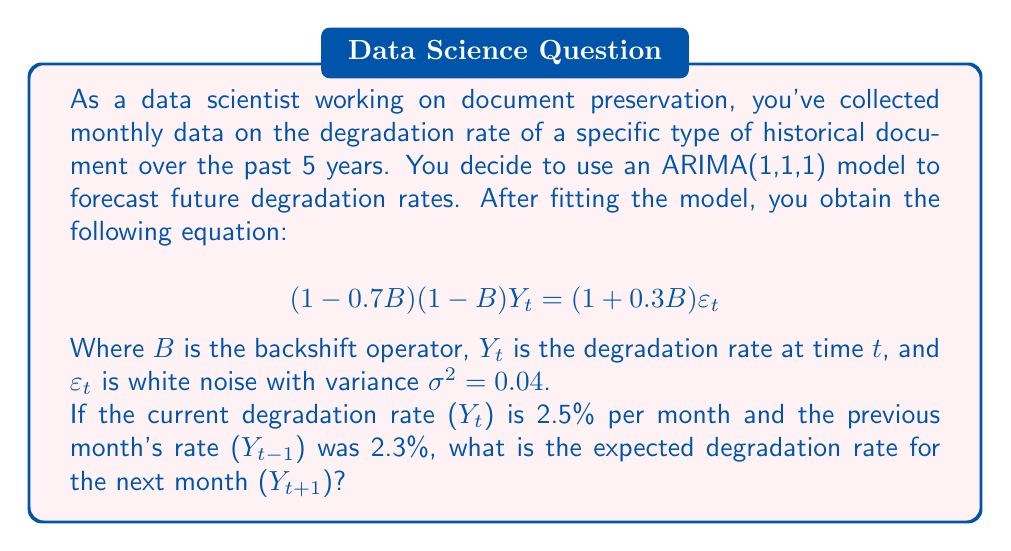Give your solution to this math problem. To solve this problem, we need to follow these steps:

1) First, let's expand the ARIMA(1,1,1) model equation:

   $$(1 - 0.7B)(1 - B)Y_t = (1 + 0.3B)\varepsilon_t$$
   $$(1 - B - 0.7B + 0.7B^2)Y_t = \varepsilon_t + 0.3B\varepsilon_t$$
   $$Y_t - Y_{t-1} - 0.7Y_{t-1} + 0.7Y_{t-2} = \varepsilon_t + 0.3\varepsilon_{t-1}$$

2) Rearrange the equation to isolate $Y_t$:

   $$Y_t = Y_{t-1} + 0.7Y_{t-1} - 0.7Y_{t-2} + \varepsilon_t + 0.3\varepsilon_{t-1}$$
   $$Y_t = 1.7Y_{t-1} - 0.7Y_{t-2} + \varepsilon_t + 0.3\varepsilon_{t-1}$$

3) To forecast $Y_{t+1}$, we shift the time index forward by 1:

   $$Y_{t+1} = 1.7Y_t - 0.7Y_{t-1} + \varepsilon_{t+1} + 0.3\varepsilon_t$$

4) For forecasting, we set future error terms to their expected value, which is zero:

   $$E[Y_{t+1}] = 1.7Y_t - 0.7Y_{t-1}$$

5) Now we can plug in the known values:
   $Y_t = 2.5$ (current rate)
   $Y_{t-1} = 2.3$ (previous month's rate)

   $$E[Y_{t+1}] = 1.7(2.5) - 0.7(2.3)$$

6) Calculate the result:

   $$E[Y_{t+1}] = 4.25 - 1.61 = 2.64$$

Therefore, the expected degradation rate for the next month is 2.64% per month.
Answer: 2.64% per month 